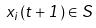<formula> <loc_0><loc_0><loc_500><loc_500>x _ { i } ( t + 1 ) \in S</formula> 